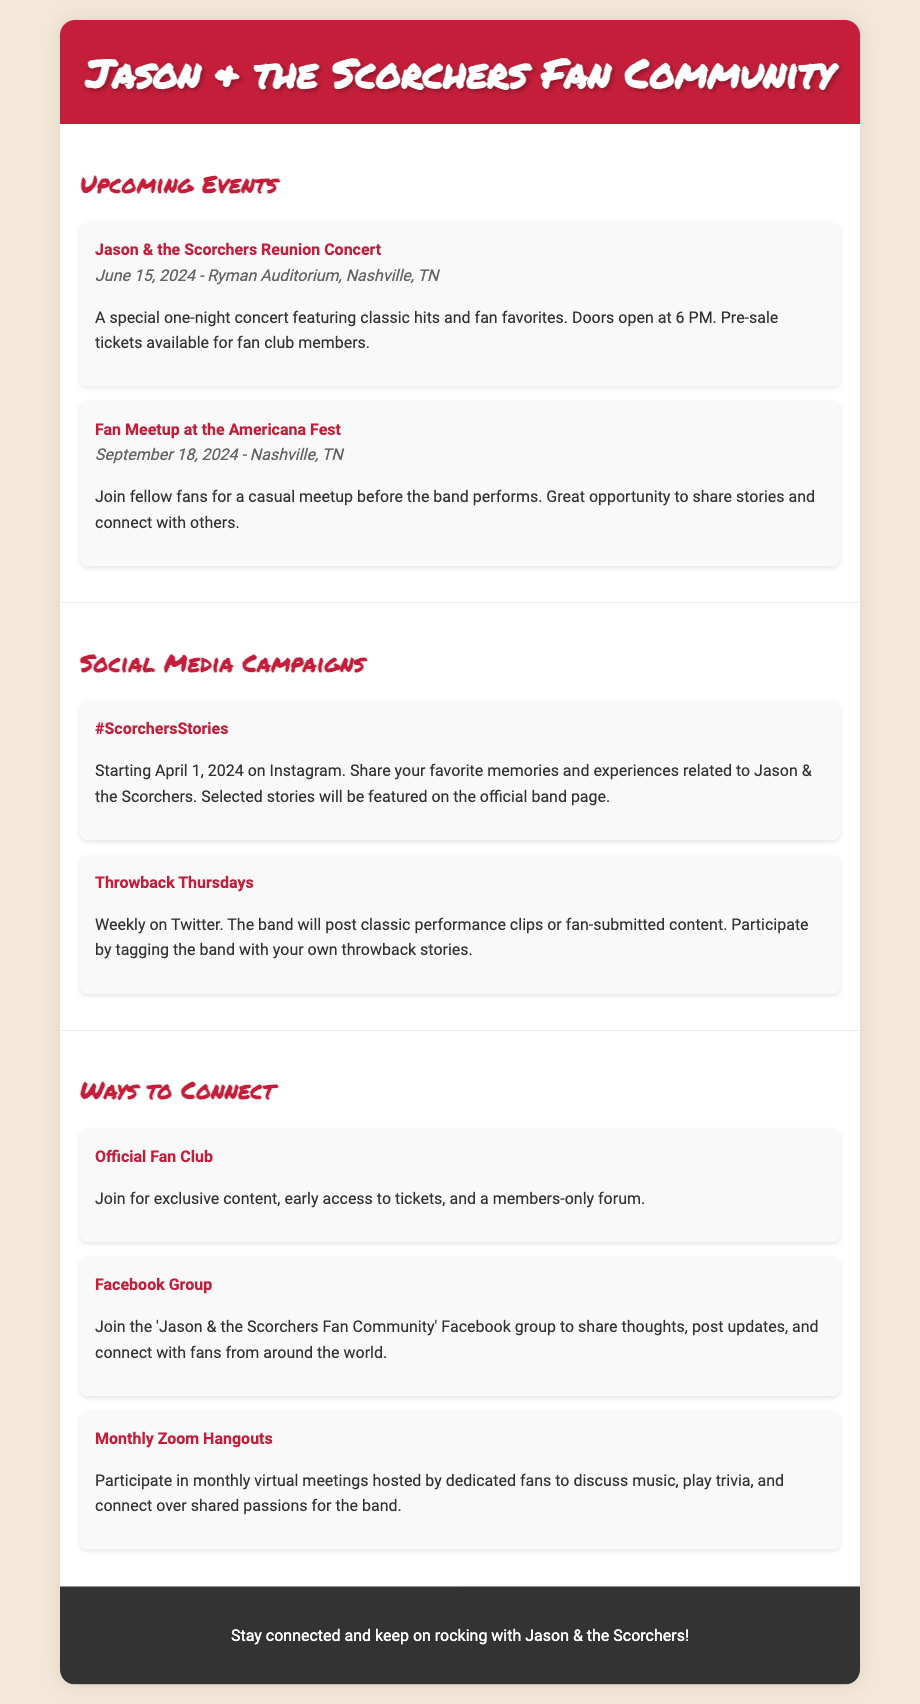what is the date of the Jason & the Scorchers Reunion Concert? The date of the concert is mentioned in the section about upcoming events as June 15, 2024.
Answer: June 15, 2024 where will the Fan Meetup at the Americana Fest take place? The location of the Fan Meetup is specified as Nashville, TN in the document.
Answer: Nashville, TN what is the hashtag for the social media campaign starting on April 1, 2024? The hashtag is listed in the social media campaigns section as #ScorchersStories.
Answer: #ScorchersStories how often do the Throwback Thursdays occur? The frequency of the Throwback Thursdays campaign is mentioned in the document as weekly.
Answer: weekly what is one way fans can connect with each other online? The document mentions several ways to connect, including joining the "Jason & the Scorchers Fan Community" Facebook group.
Answer: Facebook Group what is the venue for the Reunion Concert? The venue for the concert is provided in the event details as Ryman Auditorium.
Answer: Ryman Auditorium how will stories be selected for the #ScorchersStories campaign? The document states that selected stories will be featured on the official band page.
Answer: Featured on the official band page when is the Fan Meetup scheduled? The document specifies the date for the Fan Meetup as September 18, 2024.
Answer: September 18, 2024 what type of content can fan club members access? The document states that fan club members have access to exclusive content.
Answer: Exclusive content 